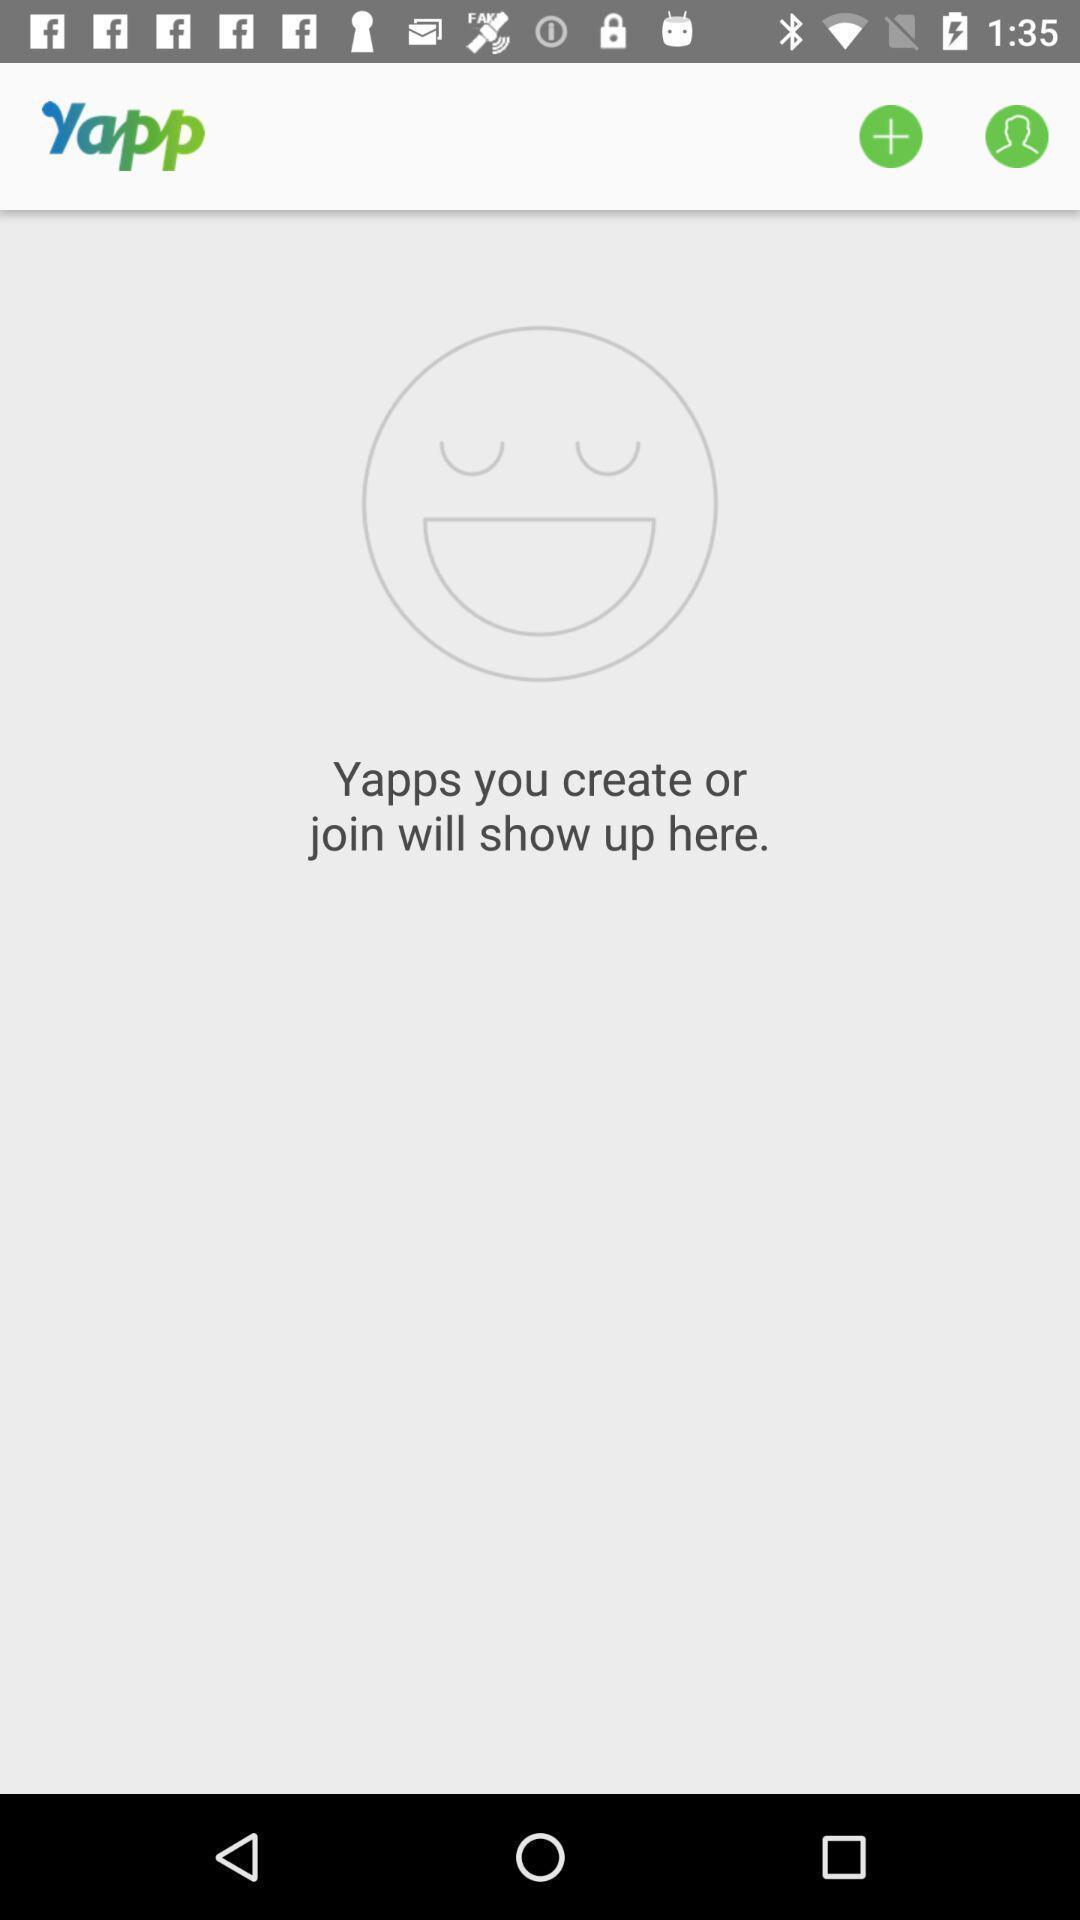Tell me what you see in this picture. Screen showing page. 